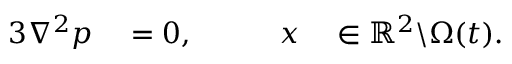<formula> <loc_0><loc_0><loc_500><loc_500>\begin{array} { r l r l } { { 3 } \nabla ^ { 2 } p } & = 0 , \quad } & { x } & \in \mathbb { R } ^ { 2 } \ \Omega ( t ) . } \end{array}</formula> 